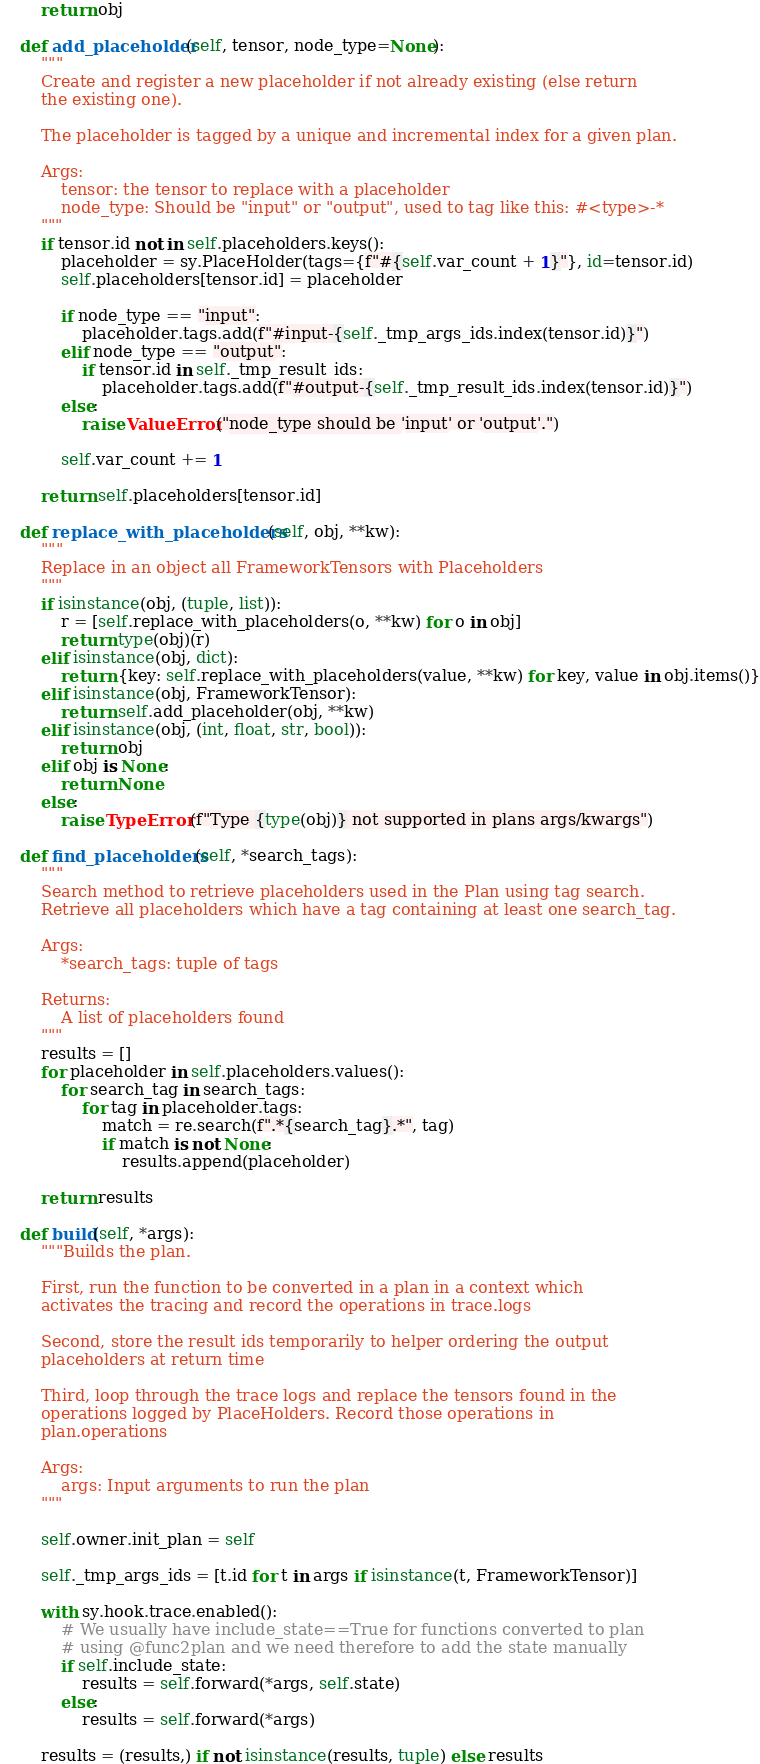Convert code to text. <code><loc_0><loc_0><loc_500><loc_500><_Python_>        return obj

    def add_placeholder(self, tensor, node_type=None):
        """
        Create and register a new placeholder if not already existing (else return
        the existing one).

        The placeholder is tagged by a unique and incremental index for a given plan.

        Args:
            tensor: the tensor to replace with a placeholder
            node_type: Should be "input" or "output", used to tag like this: #<type>-*
        """
        if tensor.id not in self.placeholders.keys():
            placeholder = sy.PlaceHolder(tags={f"#{self.var_count + 1}"}, id=tensor.id)
            self.placeholders[tensor.id] = placeholder

            if node_type == "input":
                placeholder.tags.add(f"#input-{self._tmp_args_ids.index(tensor.id)}")
            elif node_type == "output":
                if tensor.id in self._tmp_result_ids:
                    placeholder.tags.add(f"#output-{self._tmp_result_ids.index(tensor.id)}")
            else:
                raise ValueError("node_type should be 'input' or 'output'.")

            self.var_count += 1

        return self.placeholders[tensor.id]

    def replace_with_placeholders(self, obj, **kw):
        """
        Replace in an object all FrameworkTensors with Placeholders
        """
        if isinstance(obj, (tuple, list)):
            r = [self.replace_with_placeholders(o, **kw) for o in obj]
            return type(obj)(r)
        elif isinstance(obj, dict):
            return {key: self.replace_with_placeholders(value, **kw) for key, value in obj.items()}
        elif isinstance(obj, FrameworkTensor):
            return self.add_placeholder(obj, **kw)
        elif isinstance(obj, (int, float, str, bool)):
            return obj
        elif obj is None:
            return None
        else:
            raise TypeError(f"Type {type(obj)} not supported in plans args/kwargs")

    def find_placeholders(self, *search_tags):
        """
        Search method to retrieve placeholders used in the Plan using tag search.
        Retrieve all placeholders which have a tag containing at least one search_tag.

        Args:
            *search_tags: tuple of tags

        Returns:
            A list of placeholders found
        """
        results = []
        for placeholder in self.placeholders.values():
            for search_tag in search_tags:
                for tag in placeholder.tags:
                    match = re.search(f".*{search_tag}.*", tag)
                    if match is not None:
                        results.append(placeholder)

        return results

    def build(self, *args):
        """Builds the plan.

        First, run the function to be converted in a plan in a context which
        activates the tracing and record the operations in trace.logs

        Second, store the result ids temporarily to helper ordering the output
        placeholders at return time

        Third, loop through the trace logs and replace the tensors found in the
        operations logged by PlaceHolders. Record those operations in
        plan.operations

        Args:
            args: Input arguments to run the plan
        """

        self.owner.init_plan = self

        self._tmp_args_ids = [t.id for t in args if isinstance(t, FrameworkTensor)]

        with sy.hook.trace.enabled():
            # We usually have include_state==True for functions converted to plan
            # using @func2plan and we need therefore to add the state manually
            if self.include_state:
                results = self.forward(*args, self.state)
            else:
                results = self.forward(*args)

        results = (results,) if not isinstance(results, tuple) else results</code> 